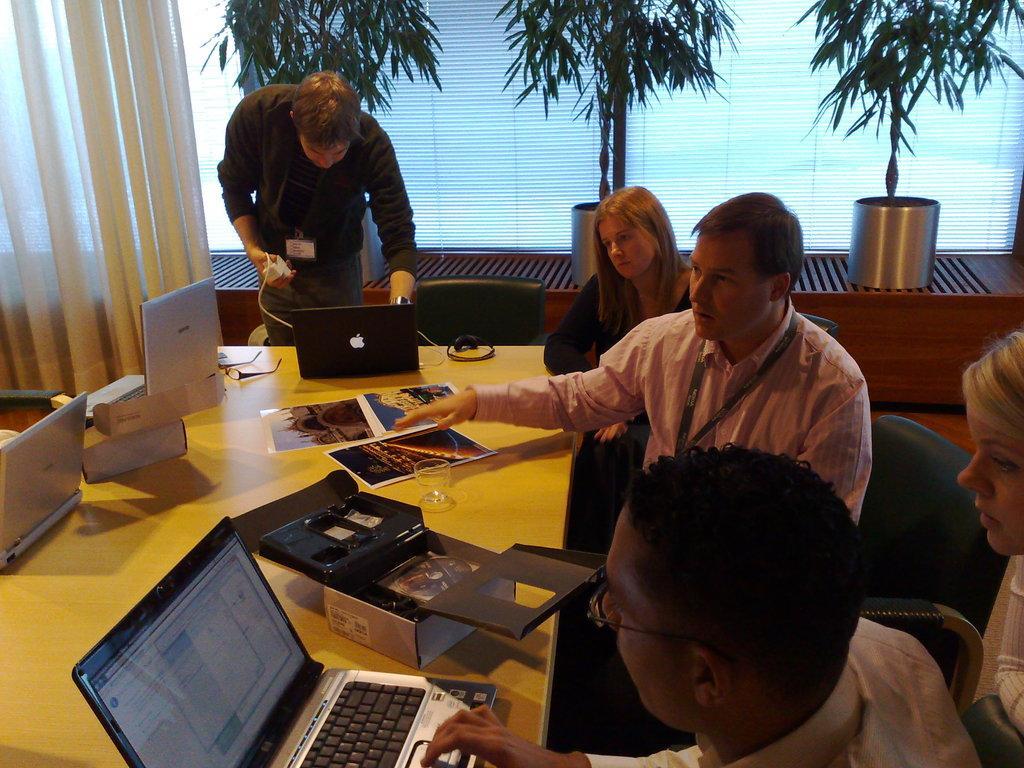Describe this image in one or two sentences. Two Men are sitting on the chairs and this man is working in the laptop this person is talking with them and beside him there is a woman who is sitting. There are plants in the middle. 